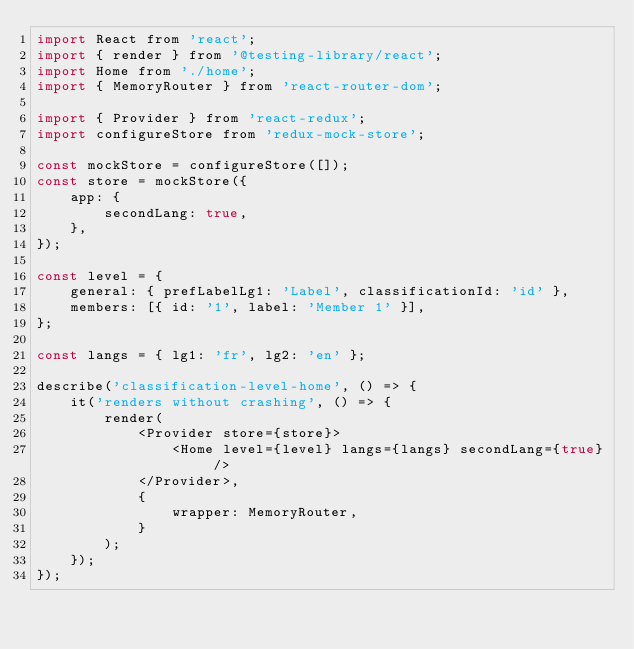<code> <loc_0><loc_0><loc_500><loc_500><_JavaScript_>import React from 'react';
import { render } from '@testing-library/react';
import Home from './home';
import { MemoryRouter } from 'react-router-dom';

import { Provider } from 'react-redux';
import configureStore from 'redux-mock-store';

const mockStore = configureStore([]);
const store = mockStore({
	app: {
		secondLang: true,
	},
});

const level = {
	general: { prefLabelLg1: 'Label', classificationId: 'id' },
	members: [{ id: '1', label: 'Member 1' }],
};

const langs = { lg1: 'fr', lg2: 'en' };

describe('classification-level-home', () => {
	it('renders without crashing', () => {
		render(
			<Provider store={store}>
				<Home level={level} langs={langs} secondLang={true} />
			</Provider>,
			{
				wrapper: MemoryRouter,
			}
		);
	});
});
</code> 